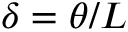Convert formula to latex. <formula><loc_0><loc_0><loc_500><loc_500>\delta = \theta / L</formula> 